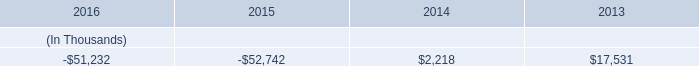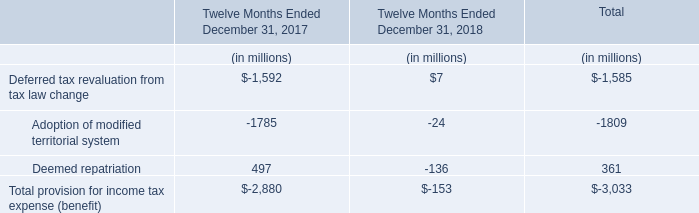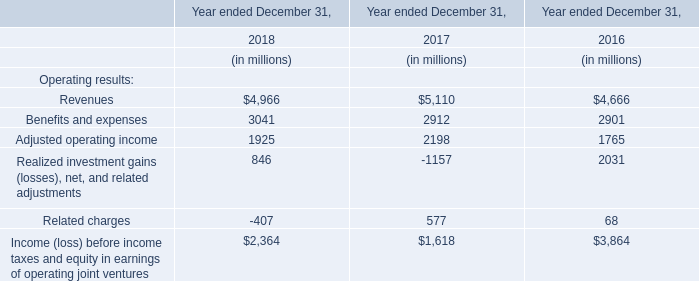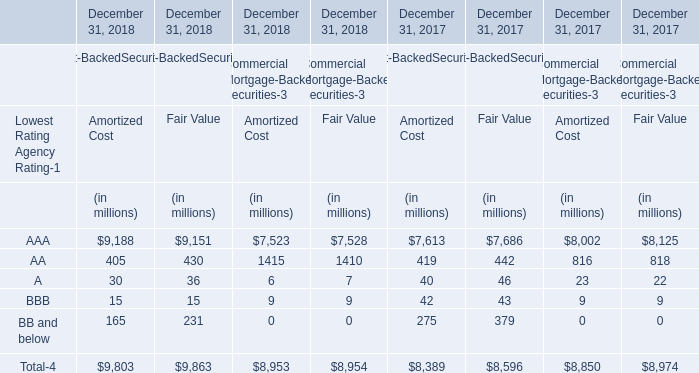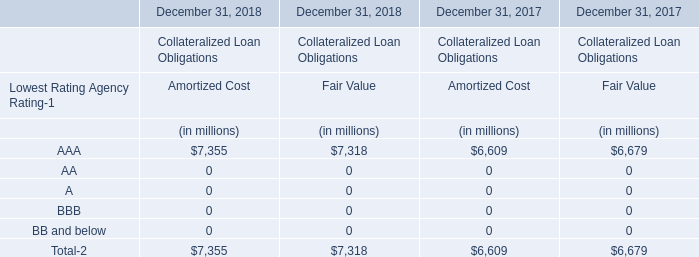What's the increasing rate of AAA for Fair Value in 2018? 
Computations: ((7318 - 6679) / 6679)
Answer: 0.09567. 